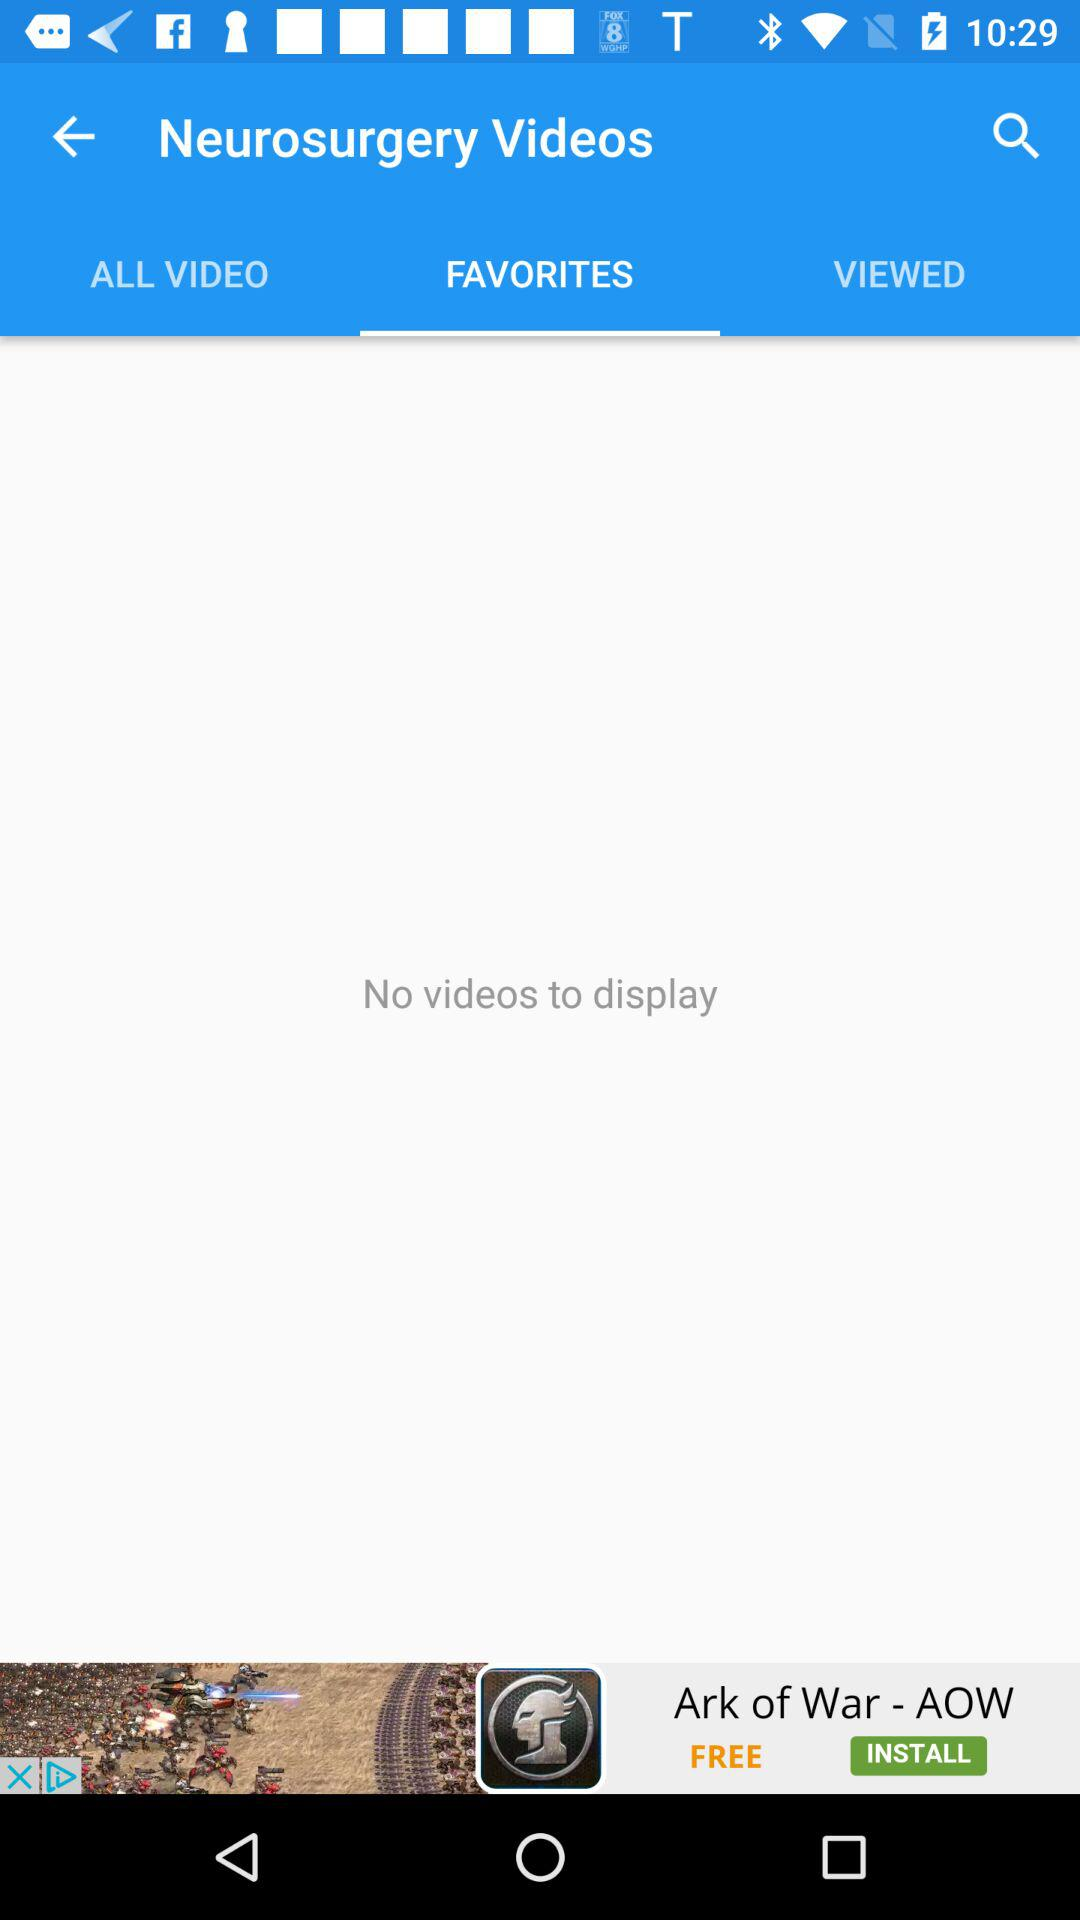Which tab is selected? The selected tab is "FAVORITES". 